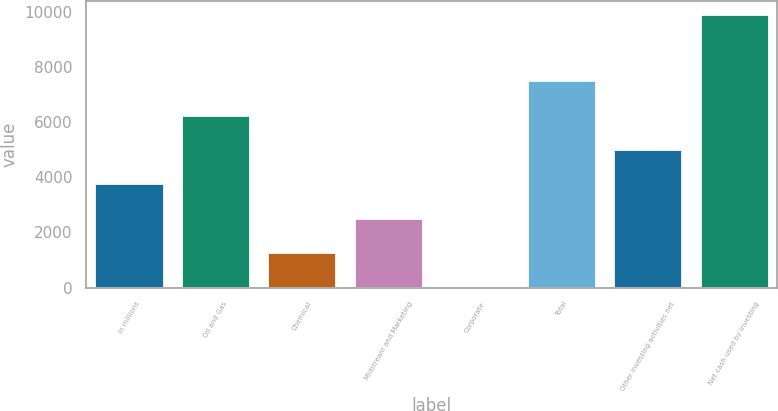Convert chart to OTSL. <chart><loc_0><loc_0><loc_500><loc_500><bar_chart><fcel>In millions<fcel>Oil and Gas<fcel>Chemical<fcel>Midstream and Marketing<fcel>Corporate<fcel>Total<fcel>Other investing activities net<fcel>Net cash used by investing<nl><fcel>3776.9<fcel>6261.5<fcel>1292.3<fcel>2534.6<fcel>50<fcel>7518<fcel>5019.2<fcel>9903<nl></chart> 